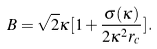<formula> <loc_0><loc_0><loc_500><loc_500>B = \sqrt { 2 } \kappa [ 1 + \frac { \sigma ( \kappa ) } { 2 \kappa ^ { 2 } r _ { c } } ] .</formula> 